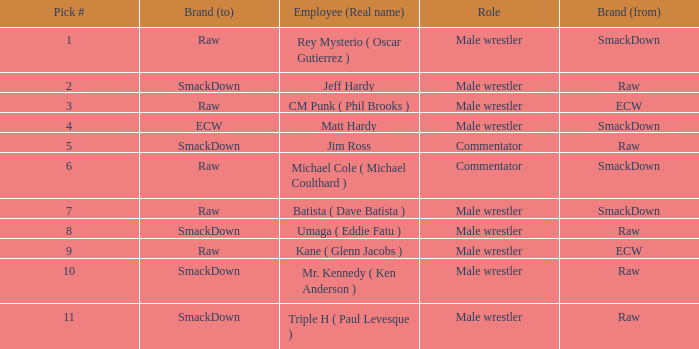What is the true name of the male wrestler from raw with a draft choice lower than 6? Jeff Hardy. 